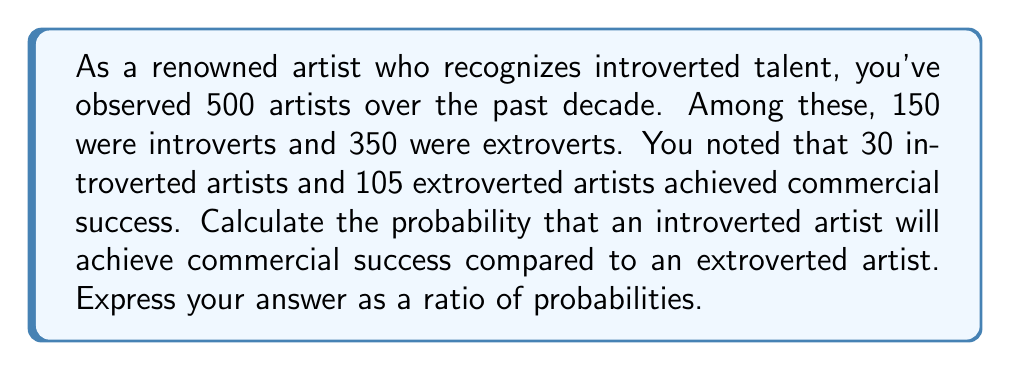Can you solve this math problem? Let's approach this step-by-step:

1. Define events:
   $I$: Artist is introverted
   $E$: Artist is extroverted
   $S$: Artist achieves commercial success

2. Calculate probabilities:

   P(S|I) = Probability of success given the artist is introverted
   $$P(S|I) = \frac{\text{Successful introverted artists}}{\text{Total introverted artists}} = \frac{30}{150} = \frac{1}{5} = 0.2$$

   P(S|E) = Probability of success given the artist is extroverted
   $$P(S|E) = \frac{\text{Successful extroverted artists}}{\text{Total extroverted artists}} = \frac{105}{350} = \frac{3}{10} = 0.3$$

3. Compare probabilities:
   To compare, we calculate the ratio of P(S|I) to P(S|E):

   $$\frac{P(S|I)}{P(S|E)} = \frac{0.2}{0.3} = \frac{2}{3}$$

This ratio means that the probability of an introverted artist achieving commercial success is 2/3 times that of an extroverted artist.
Answer: The probability that an introverted artist will achieve commercial success compared to an extroverted artist is $\frac{2}{3}$ or 0.667 to 1. 